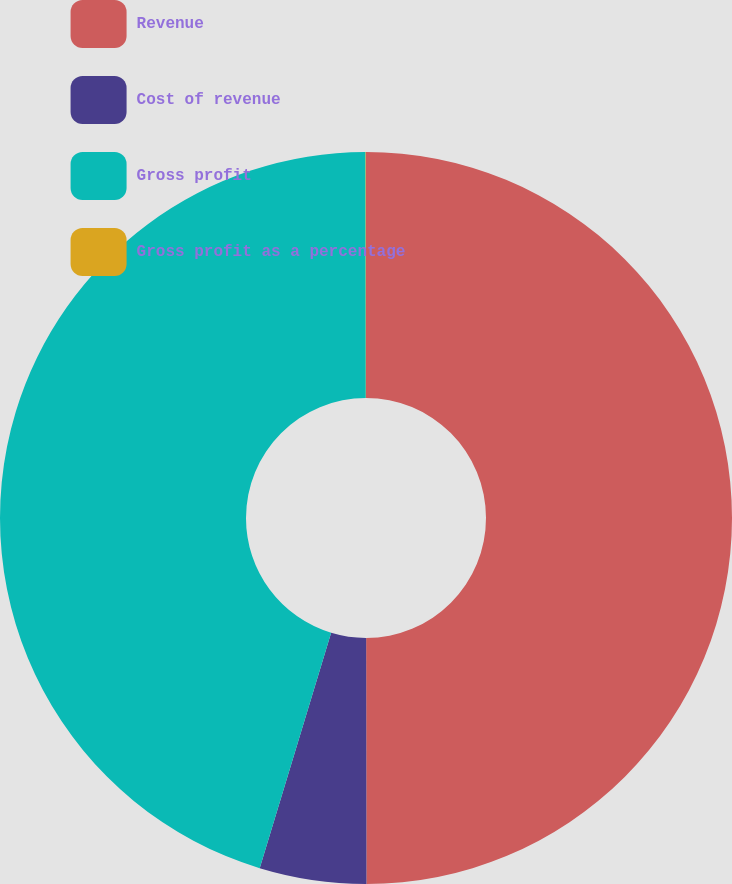Convert chart to OTSL. <chart><loc_0><loc_0><loc_500><loc_500><pie_chart><fcel>Revenue<fcel>Cost of revenue<fcel>Gross profit<fcel>Gross profit as a percentage<nl><fcel>49.98%<fcel>4.71%<fcel>45.29%<fcel>0.02%<nl></chart> 